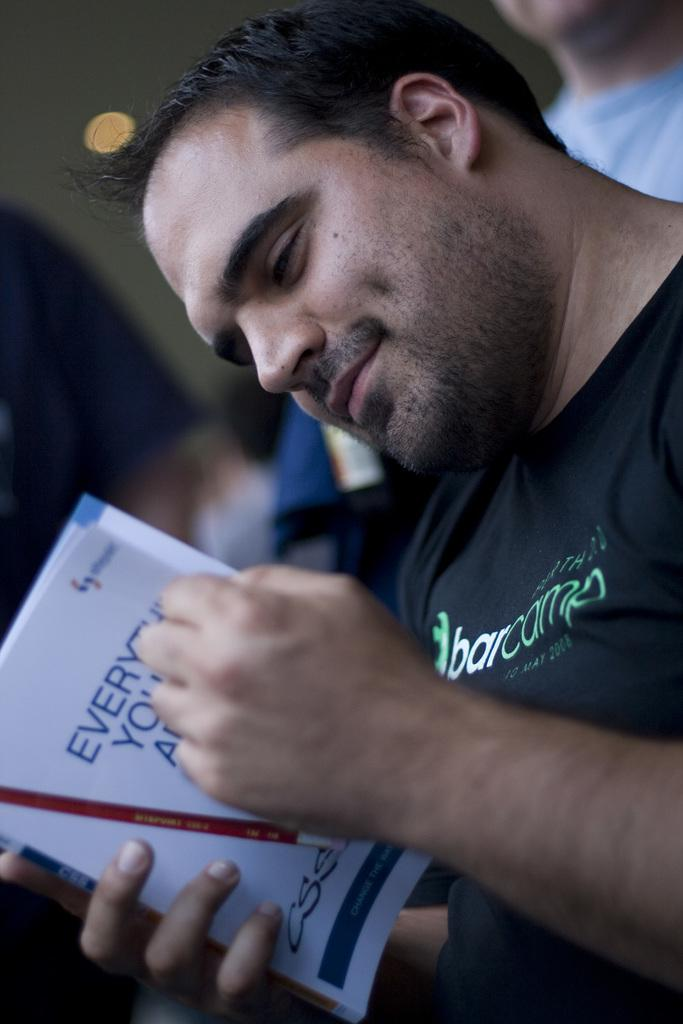Who is the main subject in the image? There is a man in the image. What is the man wearing? The man is wearing a black T-shirt. What is the man doing in the image? The man is reading a book. What can be seen in the background of the image? There is a wall in the background of the image. Are there any other people visible in the image? Yes, there is another man in the background of the image. What type of detail can be seen on the tent in the image? There is no tent present in the image. How long does it take for the man to read the book in the image? The image does not provide information about the duration of the man's reading activity. 